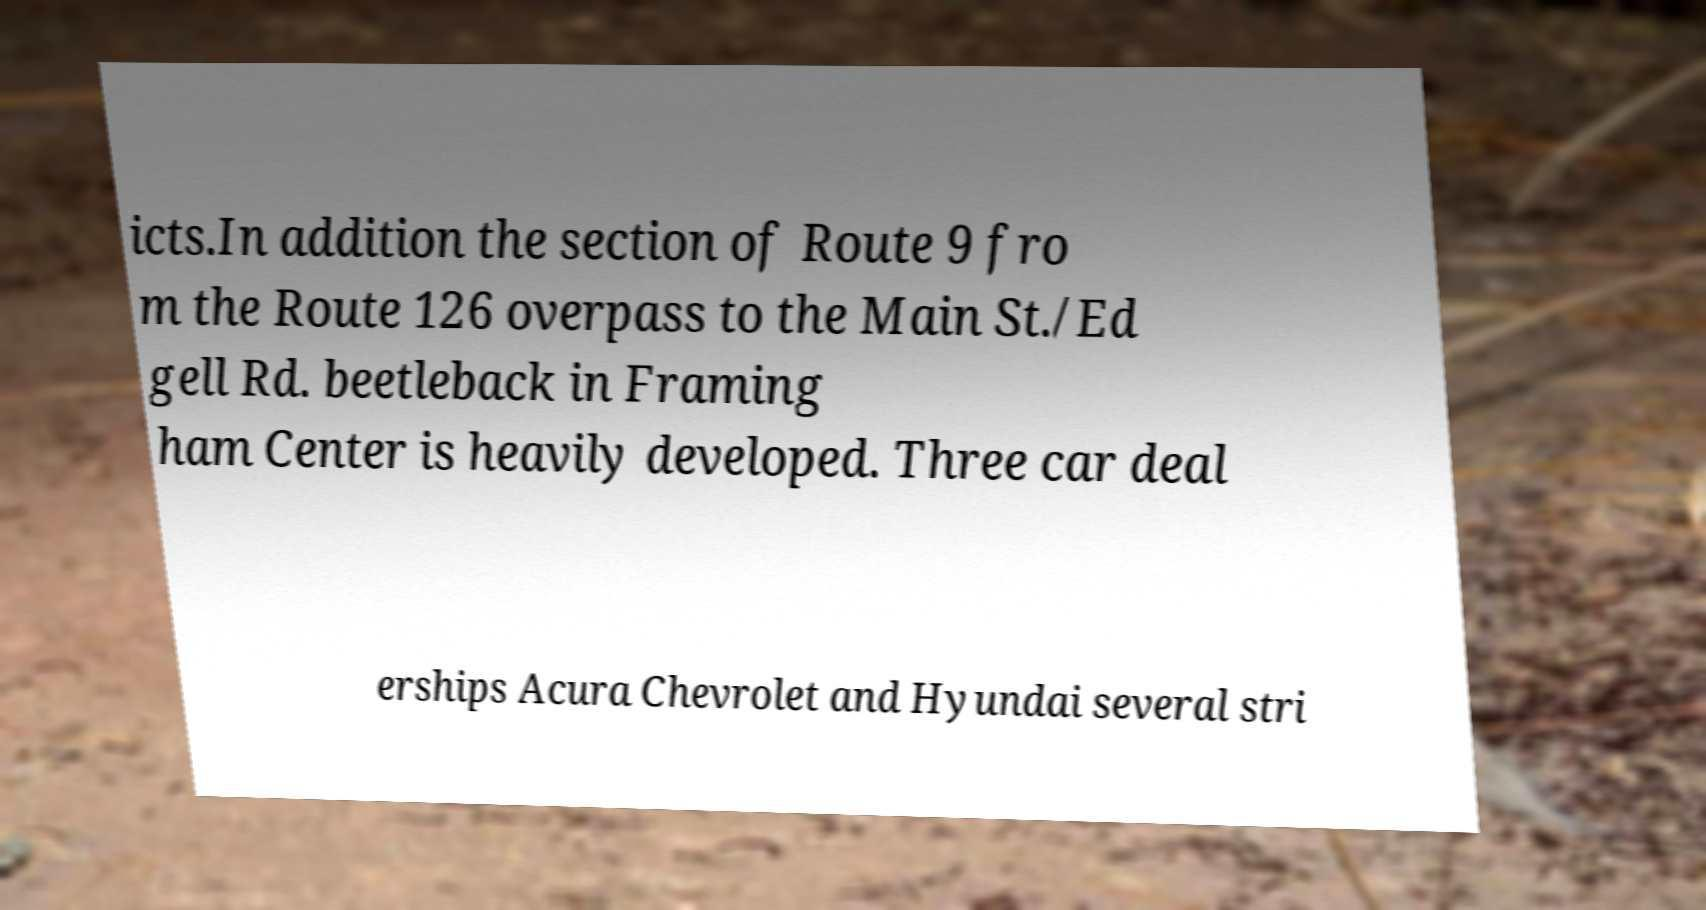I need the written content from this picture converted into text. Can you do that? icts.In addition the section of Route 9 fro m the Route 126 overpass to the Main St./Ed gell Rd. beetleback in Framing ham Center is heavily developed. Three car deal erships Acura Chevrolet and Hyundai several stri 